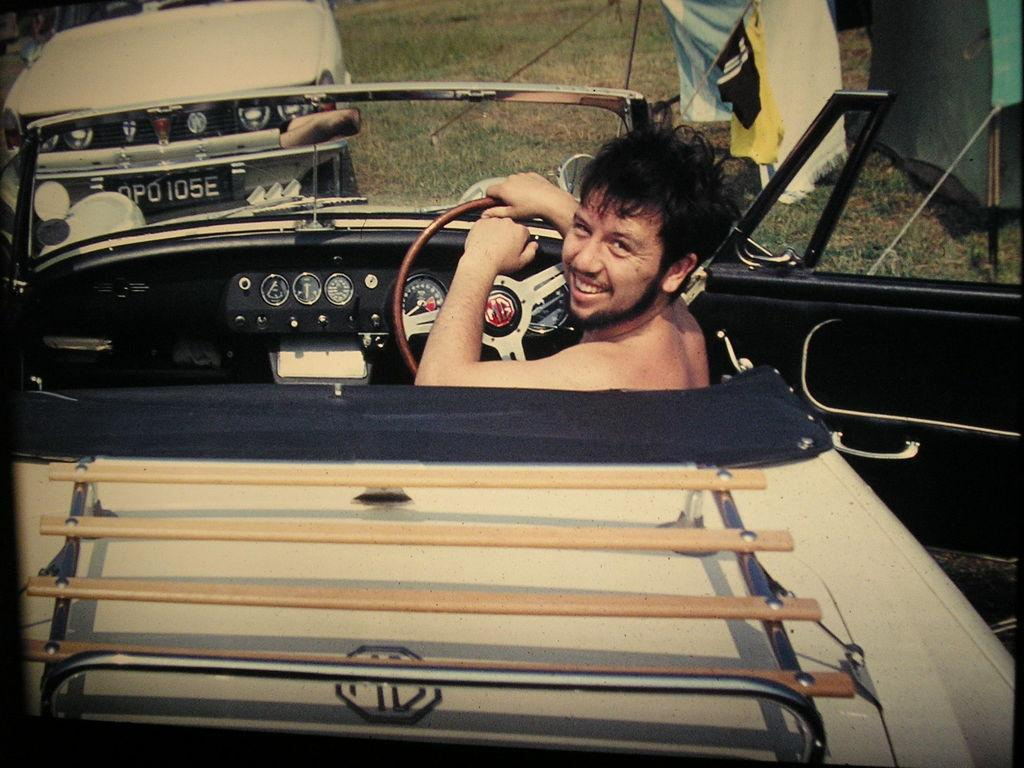What is the man in the image doing? The man is sitting in a car. What is the man's facial expression in the image? The man is smiling. How is the man interacting with the car he is sitting in? The man is holding the steering wheel with his hand. What can be seen in front of the car the man is sitting in? There is another car in front of the car the man is sitting in. What type of natural environment is visible in the image? There is grass visible in the image. What type of vest is the man wearing in the image? There is no mention of a vest in the image, so it cannot be determined if the man is wearing one. What title does the man hold in the image? There is no indication of a title or position associated with the man in the image. 